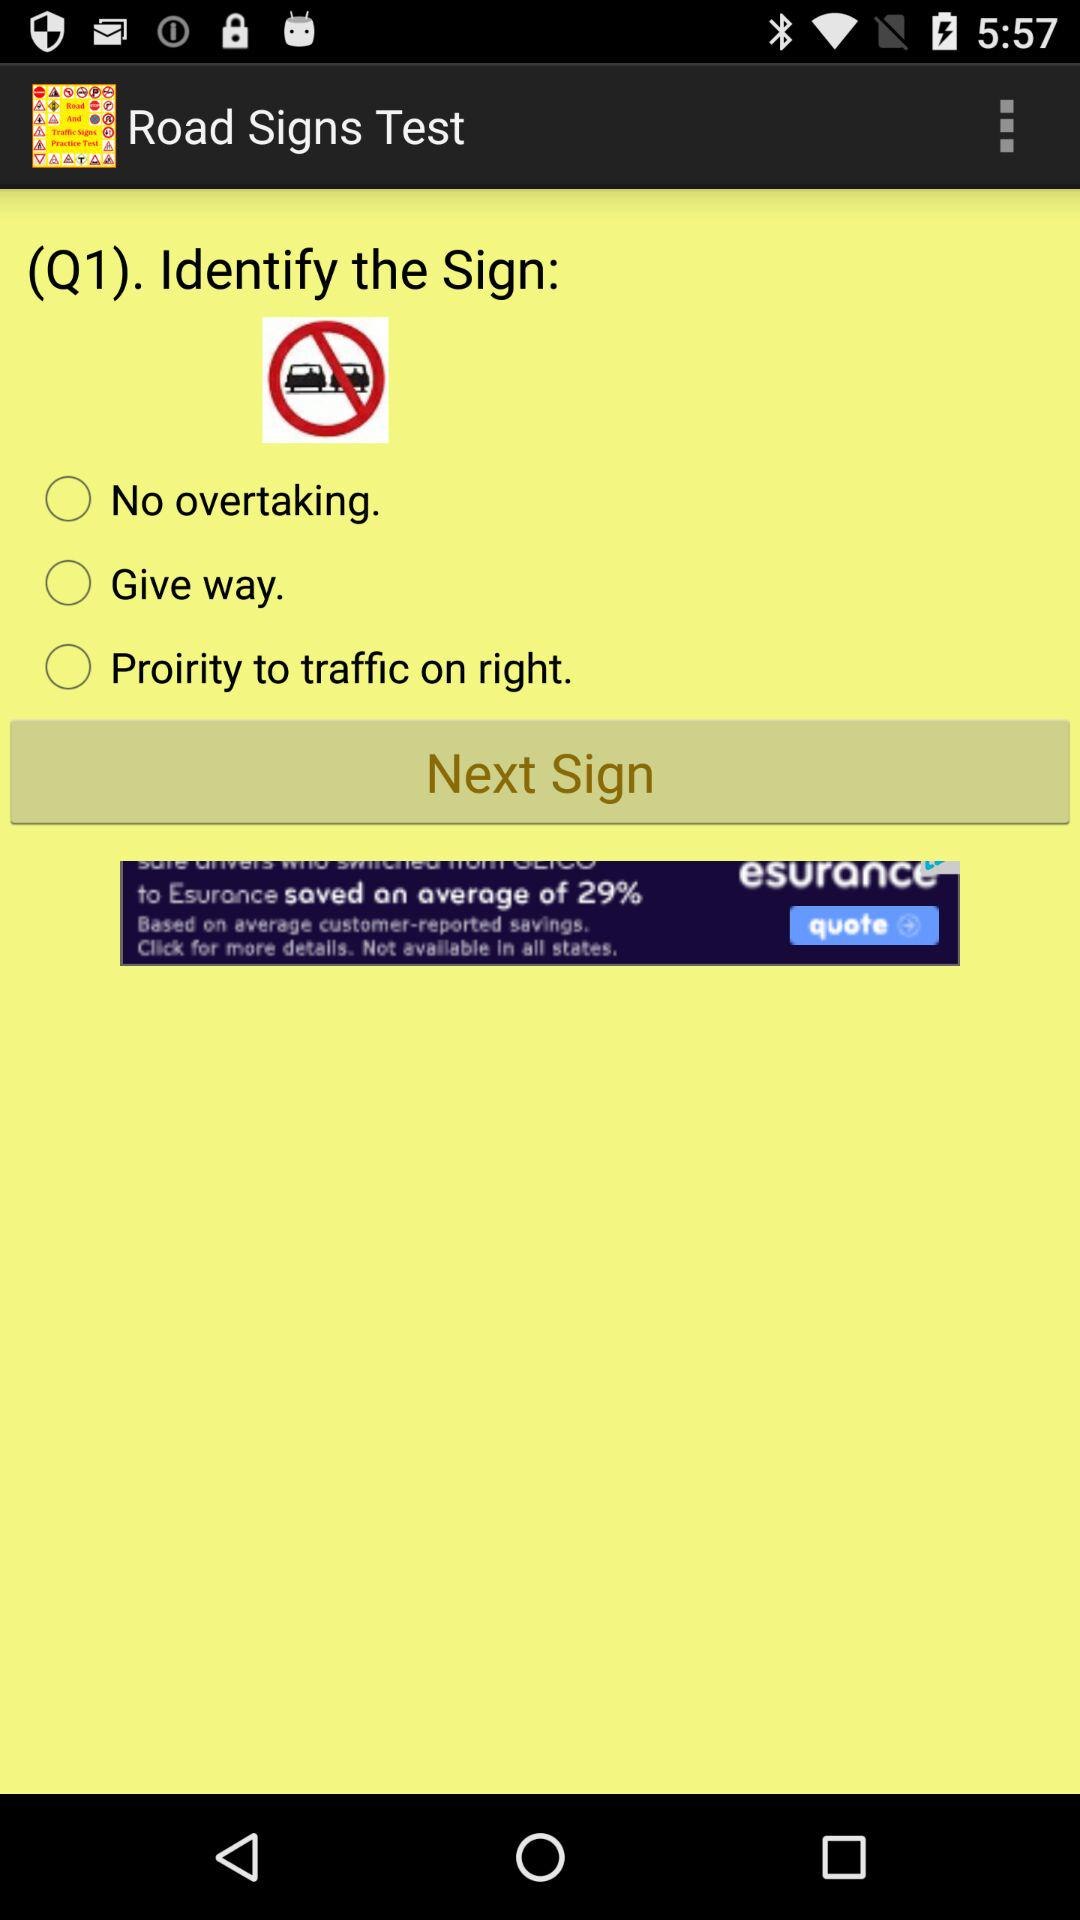What is the app name? The app name is "Road Signs Test". 